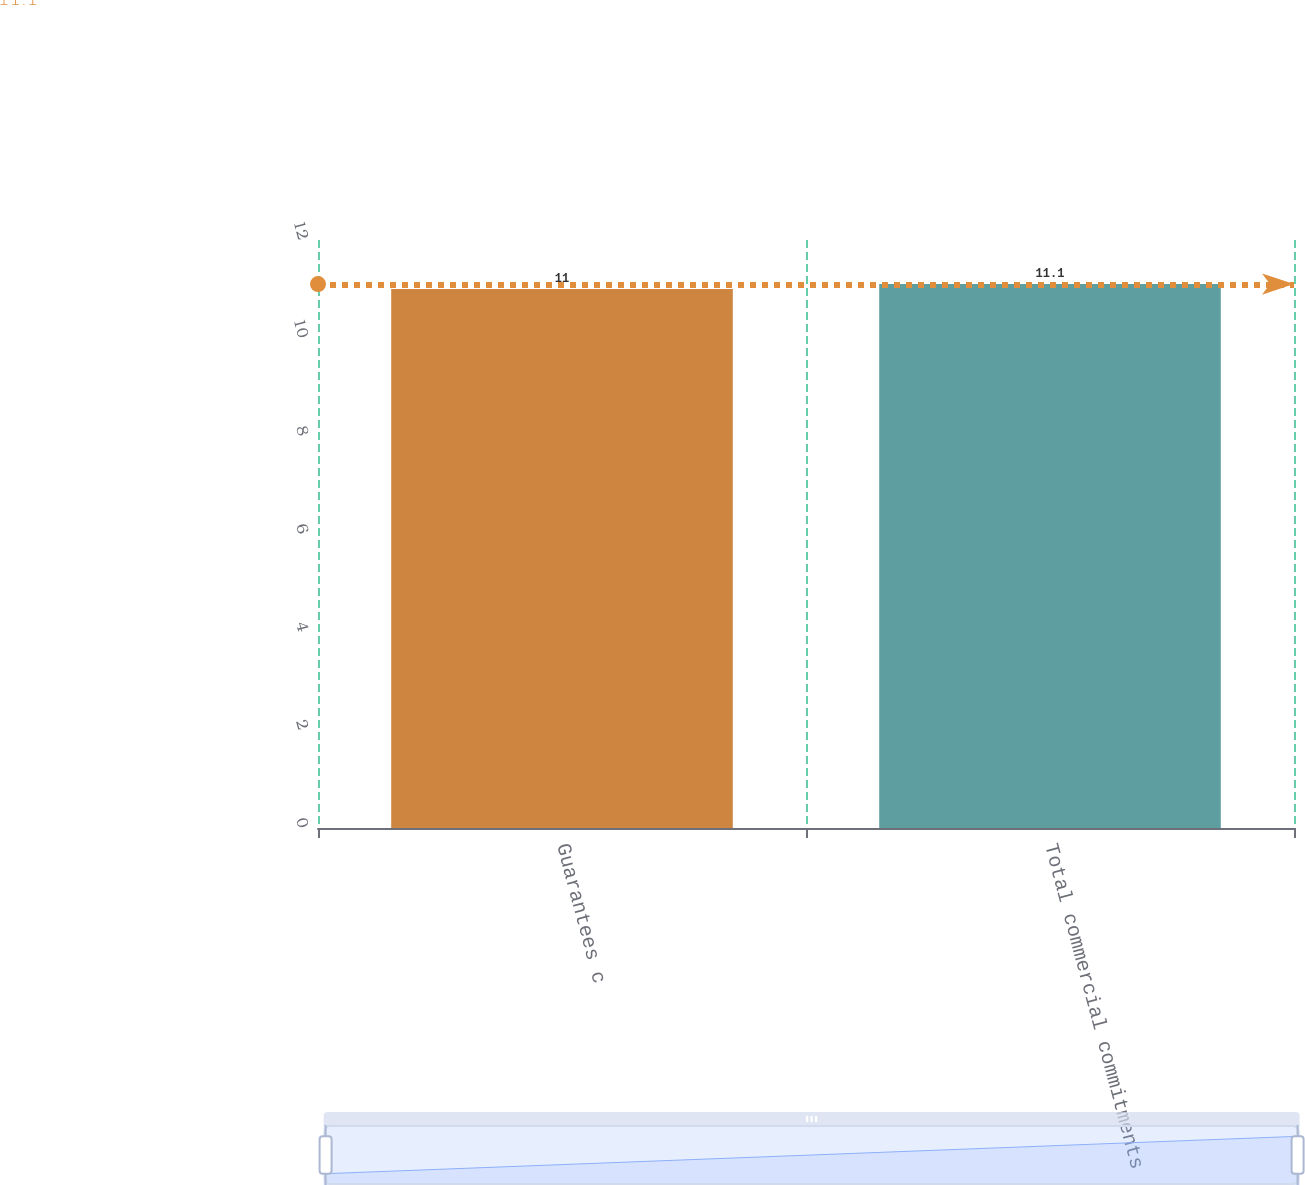Convert chart to OTSL. <chart><loc_0><loc_0><loc_500><loc_500><bar_chart><fcel>Guarantees c<fcel>Total commercial commitments<nl><fcel>11<fcel>11.1<nl></chart> 